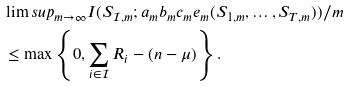<formula> <loc_0><loc_0><loc_500><loc_500>& \lim s u p _ { m \rightarrow \infty } I ( S _ { \mathcal { I } , m } ; a _ { m } b _ { m } c _ { m } e _ { m } ( S _ { 1 , m } , \dots , S _ { T , m } ) ) / m \\ & \leq \max \left \{ 0 , \sum _ { i \in \mathcal { I } } R _ { i } - ( n - \mu ) \right \} .</formula> 